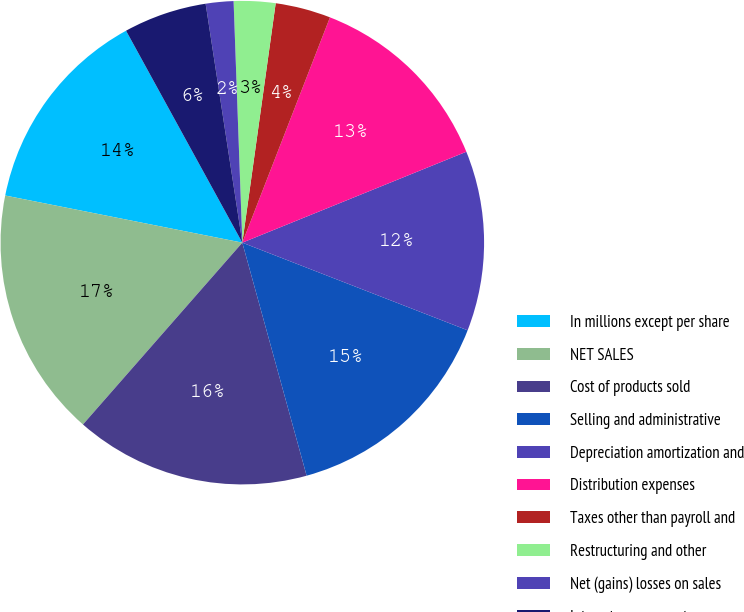<chart> <loc_0><loc_0><loc_500><loc_500><pie_chart><fcel>In millions except per share<fcel>NET SALES<fcel>Cost of products sold<fcel>Selling and administrative<fcel>Depreciation amortization and<fcel>Distribution expenses<fcel>Taxes other than payroll and<fcel>Restructuring and other<fcel>Net (gains) losses on sales<fcel>Interest expense net<nl><fcel>13.89%<fcel>16.67%<fcel>15.74%<fcel>14.81%<fcel>12.04%<fcel>12.96%<fcel>3.7%<fcel>2.78%<fcel>1.85%<fcel>5.56%<nl></chart> 